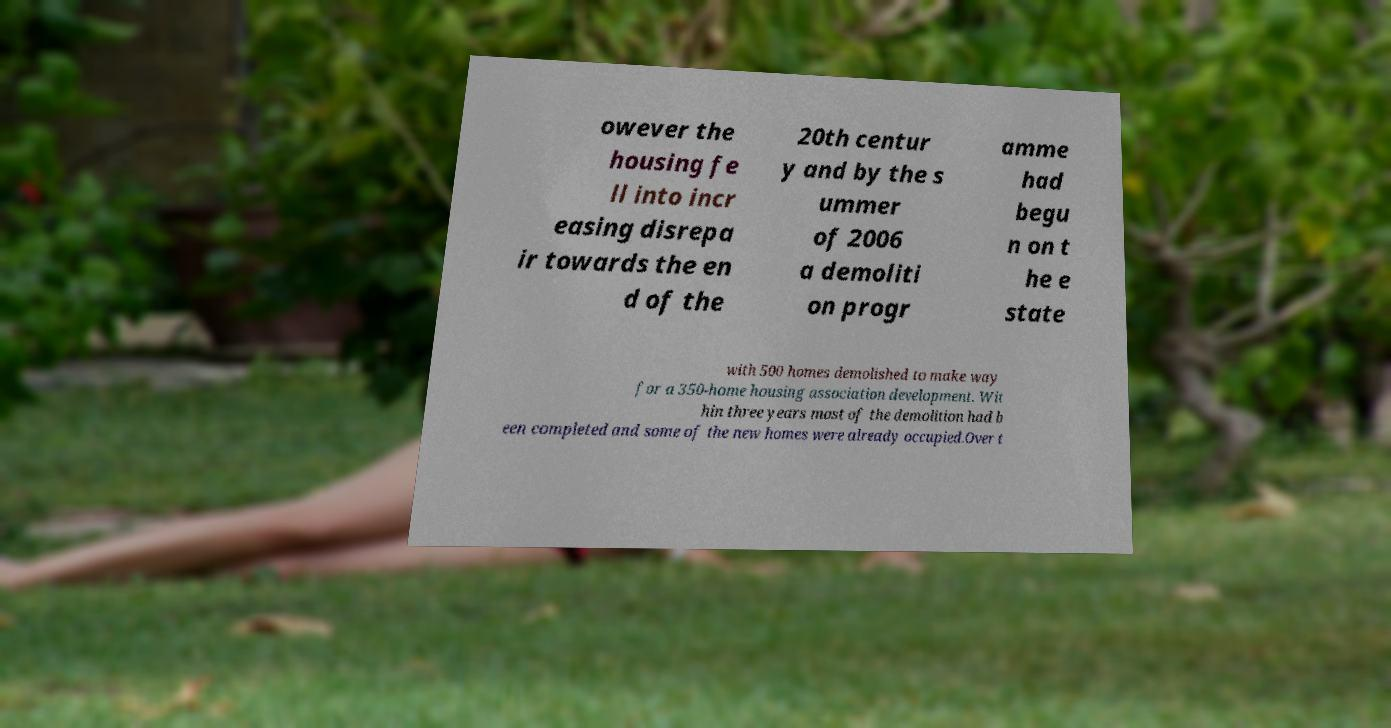Could you extract and type out the text from this image? owever the housing fe ll into incr easing disrepa ir towards the en d of the 20th centur y and by the s ummer of 2006 a demoliti on progr amme had begu n on t he e state with 500 homes demolished to make way for a 350-home housing association development. Wit hin three years most of the demolition had b een completed and some of the new homes were already occupied.Over t 